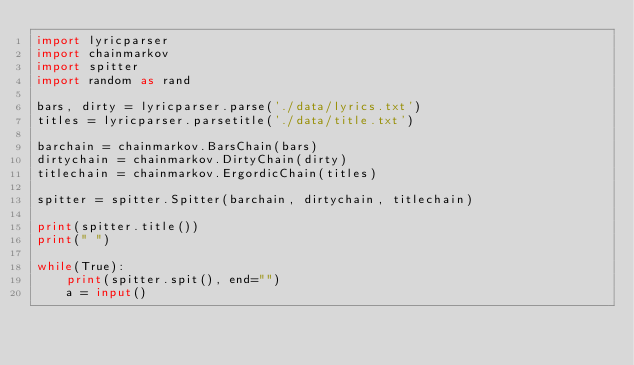<code> <loc_0><loc_0><loc_500><loc_500><_Python_>import lyricparser
import chainmarkov
import spitter
import random as rand

bars, dirty = lyricparser.parse('./data/lyrics.txt')
titles = lyricparser.parsetitle('./data/title.txt')

barchain = chainmarkov.BarsChain(bars)
dirtychain = chainmarkov.DirtyChain(dirty)
titlechain = chainmarkov.ErgordicChain(titles)

spitter = spitter.Spitter(barchain, dirtychain, titlechain)

print(spitter.title())
print(" ")

while(True):
    print(spitter.spit(), end="")
    a = input()</code> 